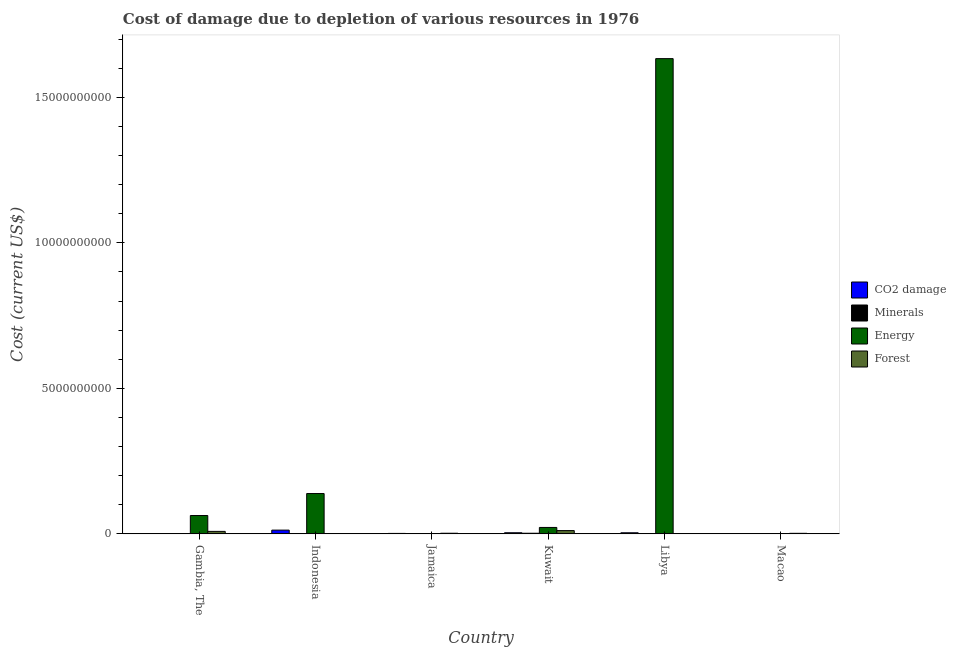Are the number of bars per tick equal to the number of legend labels?
Ensure brevity in your answer.  Yes. How many bars are there on the 1st tick from the right?
Offer a very short reply. 4. What is the label of the 4th group of bars from the left?
Keep it short and to the point. Kuwait. What is the cost of damage due to depletion of coal in Kuwait?
Make the answer very short. 3.84e+07. Across all countries, what is the maximum cost of damage due to depletion of energy?
Your answer should be compact. 1.63e+1. Across all countries, what is the minimum cost of damage due to depletion of minerals?
Your response must be concise. 8.73e+04. In which country was the cost of damage due to depletion of forests maximum?
Your answer should be compact. Kuwait. In which country was the cost of damage due to depletion of minerals minimum?
Offer a very short reply. Gambia, The. What is the total cost of damage due to depletion of minerals in the graph?
Ensure brevity in your answer.  4.59e+07. What is the difference between the cost of damage due to depletion of energy in Jamaica and that in Macao?
Offer a terse response. 2.94e+05. What is the difference between the cost of damage due to depletion of energy in Indonesia and the cost of damage due to depletion of minerals in Libya?
Offer a very short reply. 1.38e+09. What is the average cost of damage due to depletion of energy per country?
Your answer should be very brief. 3.09e+09. What is the difference between the cost of damage due to depletion of coal and cost of damage due to depletion of minerals in Gambia, The?
Your answer should be compact. 1.19e+05. In how many countries, is the cost of damage due to depletion of minerals greater than 9000000000 US$?
Your answer should be compact. 0. What is the ratio of the cost of damage due to depletion of forests in Gambia, The to that in Kuwait?
Make the answer very short. 0.76. Is the cost of damage due to depletion of minerals in Indonesia less than that in Macao?
Ensure brevity in your answer.  Yes. Is the difference between the cost of damage due to depletion of energy in Gambia, The and Indonesia greater than the difference between the cost of damage due to depletion of forests in Gambia, The and Indonesia?
Offer a terse response. No. What is the difference between the highest and the second highest cost of damage due to depletion of forests?
Your answer should be compact. 2.73e+07. What is the difference between the highest and the lowest cost of damage due to depletion of forests?
Provide a succinct answer. 1.12e+08. In how many countries, is the cost of damage due to depletion of minerals greater than the average cost of damage due to depletion of minerals taken over all countries?
Your answer should be compact. 2. Is it the case that in every country, the sum of the cost of damage due to depletion of energy and cost of damage due to depletion of coal is greater than the sum of cost of damage due to depletion of forests and cost of damage due to depletion of minerals?
Your response must be concise. No. What does the 4th bar from the left in Jamaica represents?
Your answer should be compact. Forest. What does the 4th bar from the right in Kuwait represents?
Make the answer very short. CO2 damage. Is it the case that in every country, the sum of the cost of damage due to depletion of coal and cost of damage due to depletion of minerals is greater than the cost of damage due to depletion of energy?
Keep it short and to the point. No. How many bars are there?
Your response must be concise. 24. What is the difference between two consecutive major ticks on the Y-axis?
Offer a very short reply. 5.00e+09. Are the values on the major ticks of Y-axis written in scientific E-notation?
Your answer should be very brief. No. Where does the legend appear in the graph?
Keep it short and to the point. Center right. How many legend labels are there?
Keep it short and to the point. 4. What is the title of the graph?
Give a very brief answer. Cost of damage due to depletion of various resources in 1976 . What is the label or title of the X-axis?
Your response must be concise. Country. What is the label or title of the Y-axis?
Your response must be concise. Cost (current US$). What is the Cost (current US$) of CO2 damage in Gambia, The?
Your answer should be compact. 2.06e+05. What is the Cost (current US$) of Minerals in Gambia, The?
Give a very brief answer. 8.73e+04. What is the Cost (current US$) in Energy in Gambia, The?
Keep it short and to the point. 6.30e+08. What is the Cost (current US$) in Forest in Gambia, The?
Make the answer very short. 8.54e+07. What is the Cost (current US$) in CO2 damage in Indonesia?
Provide a succinct answer. 1.28e+08. What is the Cost (current US$) in Minerals in Indonesia?
Keep it short and to the point. 6.60e+06. What is the Cost (current US$) of Energy in Indonesia?
Your response must be concise. 1.39e+09. What is the Cost (current US$) in Forest in Indonesia?
Make the answer very short. 1.20e+06. What is the Cost (current US$) in CO2 damage in Jamaica?
Your response must be concise. 1.51e+07. What is the Cost (current US$) in Minerals in Jamaica?
Offer a very short reply. 1.73e+06. What is the Cost (current US$) of Energy in Jamaica?
Offer a terse response. 4.30e+05. What is the Cost (current US$) in Forest in Jamaica?
Keep it short and to the point. 2.11e+07. What is the Cost (current US$) in CO2 damage in Kuwait?
Give a very brief answer. 3.84e+07. What is the Cost (current US$) in Minerals in Kuwait?
Your response must be concise. 2.10e+07. What is the Cost (current US$) in Energy in Kuwait?
Provide a succinct answer. 2.21e+08. What is the Cost (current US$) of Forest in Kuwait?
Offer a terse response. 1.13e+08. What is the Cost (current US$) in CO2 damage in Libya?
Your response must be concise. 3.72e+07. What is the Cost (current US$) in Minerals in Libya?
Offer a terse response. 9.51e+06. What is the Cost (current US$) in Energy in Libya?
Offer a terse response. 1.63e+1. What is the Cost (current US$) of Forest in Libya?
Provide a short and direct response. 6.67e+05. What is the Cost (current US$) in CO2 damage in Macao?
Your response must be concise. 5.26e+05. What is the Cost (current US$) in Minerals in Macao?
Give a very brief answer. 6.89e+06. What is the Cost (current US$) of Energy in Macao?
Your answer should be compact. 1.36e+05. What is the Cost (current US$) of Forest in Macao?
Your response must be concise. 1.89e+07. Across all countries, what is the maximum Cost (current US$) of CO2 damage?
Your response must be concise. 1.28e+08. Across all countries, what is the maximum Cost (current US$) in Minerals?
Offer a very short reply. 2.10e+07. Across all countries, what is the maximum Cost (current US$) in Energy?
Ensure brevity in your answer.  1.63e+1. Across all countries, what is the maximum Cost (current US$) of Forest?
Give a very brief answer. 1.13e+08. Across all countries, what is the minimum Cost (current US$) in CO2 damage?
Ensure brevity in your answer.  2.06e+05. Across all countries, what is the minimum Cost (current US$) in Minerals?
Make the answer very short. 8.73e+04. Across all countries, what is the minimum Cost (current US$) of Energy?
Provide a succinct answer. 1.36e+05. Across all countries, what is the minimum Cost (current US$) in Forest?
Provide a short and direct response. 6.67e+05. What is the total Cost (current US$) of CO2 damage in the graph?
Your answer should be very brief. 2.20e+08. What is the total Cost (current US$) of Minerals in the graph?
Make the answer very short. 4.59e+07. What is the total Cost (current US$) of Energy in the graph?
Keep it short and to the point. 1.86e+1. What is the total Cost (current US$) of Forest in the graph?
Your answer should be compact. 2.40e+08. What is the difference between the Cost (current US$) of CO2 damage in Gambia, The and that in Indonesia?
Ensure brevity in your answer.  -1.28e+08. What is the difference between the Cost (current US$) of Minerals in Gambia, The and that in Indonesia?
Offer a very short reply. -6.51e+06. What is the difference between the Cost (current US$) in Energy in Gambia, The and that in Indonesia?
Your answer should be very brief. -7.55e+08. What is the difference between the Cost (current US$) of Forest in Gambia, The and that in Indonesia?
Ensure brevity in your answer.  8.42e+07. What is the difference between the Cost (current US$) of CO2 damage in Gambia, The and that in Jamaica?
Provide a succinct answer. -1.49e+07. What is the difference between the Cost (current US$) in Minerals in Gambia, The and that in Jamaica?
Your answer should be compact. -1.64e+06. What is the difference between the Cost (current US$) in Energy in Gambia, The and that in Jamaica?
Provide a succinct answer. 6.30e+08. What is the difference between the Cost (current US$) of Forest in Gambia, The and that in Jamaica?
Make the answer very short. 6.44e+07. What is the difference between the Cost (current US$) in CO2 damage in Gambia, The and that in Kuwait?
Keep it short and to the point. -3.82e+07. What is the difference between the Cost (current US$) of Minerals in Gambia, The and that in Kuwait?
Provide a short and direct response. -2.10e+07. What is the difference between the Cost (current US$) of Energy in Gambia, The and that in Kuwait?
Offer a terse response. 4.10e+08. What is the difference between the Cost (current US$) of Forest in Gambia, The and that in Kuwait?
Your response must be concise. -2.73e+07. What is the difference between the Cost (current US$) in CO2 damage in Gambia, The and that in Libya?
Offer a very short reply. -3.70e+07. What is the difference between the Cost (current US$) in Minerals in Gambia, The and that in Libya?
Make the answer very short. -9.42e+06. What is the difference between the Cost (current US$) of Energy in Gambia, The and that in Libya?
Your response must be concise. -1.57e+1. What is the difference between the Cost (current US$) of Forest in Gambia, The and that in Libya?
Provide a succinct answer. 8.48e+07. What is the difference between the Cost (current US$) of CO2 damage in Gambia, The and that in Macao?
Offer a very short reply. -3.20e+05. What is the difference between the Cost (current US$) in Minerals in Gambia, The and that in Macao?
Your answer should be very brief. -6.80e+06. What is the difference between the Cost (current US$) in Energy in Gambia, The and that in Macao?
Your answer should be compact. 6.30e+08. What is the difference between the Cost (current US$) in Forest in Gambia, The and that in Macao?
Offer a terse response. 6.65e+07. What is the difference between the Cost (current US$) in CO2 damage in Indonesia and that in Jamaica?
Your answer should be very brief. 1.13e+08. What is the difference between the Cost (current US$) of Minerals in Indonesia and that in Jamaica?
Provide a short and direct response. 4.87e+06. What is the difference between the Cost (current US$) in Energy in Indonesia and that in Jamaica?
Keep it short and to the point. 1.38e+09. What is the difference between the Cost (current US$) of Forest in Indonesia and that in Jamaica?
Make the answer very short. -1.99e+07. What is the difference between the Cost (current US$) in CO2 damage in Indonesia and that in Kuwait?
Make the answer very short. 9.01e+07. What is the difference between the Cost (current US$) of Minerals in Indonesia and that in Kuwait?
Your response must be concise. -1.44e+07. What is the difference between the Cost (current US$) of Energy in Indonesia and that in Kuwait?
Your answer should be compact. 1.16e+09. What is the difference between the Cost (current US$) of Forest in Indonesia and that in Kuwait?
Keep it short and to the point. -1.12e+08. What is the difference between the Cost (current US$) of CO2 damage in Indonesia and that in Libya?
Your response must be concise. 9.12e+07. What is the difference between the Cost (current US$) of Minerals in Indonesia and that in Libya?
Offer a terse response. -2.91e+06. What is the difference between the Cost (current US$) of Energy in Indonesia and that in Libya?
Offer a very short reply. -1.49e+1. What is the difference between the Cost (current US$) in Forest in Indonesia and that in Libya?
Your response must be concise. 5.35e+05. What is the difference between the Cost (current US$) of CO2 damage in Indonesia and that in Macao?
Your answer should be compact. 1.28e+08. What is the difference between the Cost (current US$) of Minerals in Indonesia and that in Macao?
Offer a terse response. -2.88e+05. What is the difference between the Cost (current US$) in Energy in Indonesia and that in Macao?
Offer a terse response. 1.39e+09. What is the difference between the Cost (current US$) of Forest in Indonesia and that in Macao?
Give a very brief answer. -1.77e+07. What is the difference between the Cost (current US$) in CO2 damage in Jamaica and that in Kuwait?
Offer a very short reply. -2.33e+07. What is the difference between the Cost (current US$) of Minerals in Jamaica and that in Kuwait?
Offer a very short reply. -1.93e+07. What is the difference between the Cost (current US$) in Energy in Jamaica and that in Kuwait?
Provide a succinct answer. -2.20e+08. What is the difference between the Cost (current US$) in Forest in Jamaica and that in Kuwait?
Your answer should be very brief. -9.17e+07. What is the difference between the Cost (current US$) of CO2 damage in Jamaica and that in Libya?
Make the answer very short. -2.21e+07. What is the difference between the Cost (current US$) of Minerals in Jamaica and that in Libya?
Your response must be concise. -7.78e+06. What is the difference between the Cost (current US$) of Energy in Jamaica and that in Libya?
Offer a terse response. -1.63e+1. What is the difference between the Cost (current US$) in Forest in Jamaica and that in Libya?
Offer a very short reply. 2.04e+07. What is the difference between the Cost (current US$) in CO2 damage in Jamaica and that in Macao?
Your response must be concise. 1.46e+07. What is the difference between the Cost (current US$) of Minerals in Jamaica and that in Macao?
Offer a very short reply. -5.16e+06. What is the difference between the Cost (current US$) of Energy in Jamaica and that in Macao?
Your answer should be compact. 2.94e+05. What is the difference between the Cost (current US$) of Forest in Jamaica and that in Macao?
Make the answer very short. 2.19e+06. What is the difference between the Cost (current US$) in CO2 damage in Kuwait and that in Libya?
Provide a short and direct response. 1.16e+06. What is the difference between the Cost (current US$) in Minerals in Kuwait and that in Libya?
Offer a very short reply. 1.15e+07. What is the difference between the Cost (current US$) of Energy in Kuwait and that in Libya?
Offer a very short reply. -1.61e+1. What is the difference between the Cost (current US$) of Forest in Kuwait and that in Libya?
Provide a succinct answer. 1.12e+08. What is the difference between the Cost (current US$) in CO2 damage in Kuwait and that in Macao?
Your response must be concise. 3.79e+07. What is the difference between the Cost (current US$) in Minerals in Kuwait and that in Macao?
Provide a short and direct response. 1.42e+07. What is the difference between the Cost (current US$) in Energy in Kuwait and that in Macao?
Provide a succinct answer. 2.20e+08. What is the difference between the Cost (current US$) of Forest in Kuwait and that in Macao?
Keep it short and to the point. 9.39e+07. What is the difference between the Cost (current US$) of CO2 damage in Libya and that in Macao?
Give a very brief answer. 3.67e+07. What is the difference between the Cost (current US$) of Minerals in Libya and that in Macao?
Offer a terse response. 2.62e+06. What is the difference between the Cost (current US$) in Energy in Libya and that in Macao?
Your answer should be very brief. 1.63e+1. What is the difference between the Cost (current US$) of Forest in Libya and that in Macao?
Provide a succinct answer. -1.82e+07. What is the difference between the Cost (current US$) of CO2 damage in Gambia, The and the Cost (current US$) of Minerals in Indonesia?
Keep it short and to the point. -6.39e+06. What is the difference between the Cost (current US$) in CO2 damage in Gambia, The and the Cost (current US$) in Energy in Indonesia?
Your answer should be very brief. -1.39e+09. What is the difference between the Cost (current US$) in CO2 damage in Gambia, The and the Cost (current US$) in Forest in Indonesia?
Offer a terse response. -9.96e+05. What is the difference between the Cost (current US$) in Minerals in Gambia, The and the Cost (current US$) in Energy in Indonesia?
Your answer should be compact. -1.39e+09. What is the difference between the Cost (current US$) in Minerals in Gambia, The and the Cost (current US$) in Forest in Indonesia?
Keep it short and to the point. -1.11e+06. What is the difference between the Cost (current US$) in Energy in Gambia, The and the Cost (current US$) in Forest in Indonesia?
Your answer should be very brief. 6.29e+08. What is the difference between the Cost (current US$) in CO2 damage in Gambia, The and the Cost (current US$) in Minerals in Jamaica?
Keep it short and to the point. -1.52e+06. What is the difference between the Cost (current US$) of CO2 damage in Gambia, The and the Cost (current US$) of Energy in Jamaica?
Your response must be concise. -2.25e+05. What is the difference between the Cost (current US$) in CO2 damage in Gambia, The and the Cost (current US$) in Forest in Jamaica?
Offer a very short reply. -2.09e+07. What is the difference between the Cost (current US$) of Minerals in Gambia, The and the Cost (current US$) of Energy in Jamaica?
Provide a succinct answer. -3.43e+05. What is the difference between the Cost (current US$) in Minerals in Gambia, The and the Cost (current US$) in Forest in Jamaica?
Offer a terse response. -2.10e+07. What is the difference between the Cost (current US$) of Energy in Gambia, The and the Cost (current US$) of Forest in Jamaica?
Offer a very short reply. 6.09e+08. What is the difference between the Cost (current US$) of CO2 damage in Gambia, The and the Cost (current US$) of Minerals in Kuwait?
Your answer should be very brief. -2.08e+07. What is the difference between the Cost (current US$) of CO2 damage in Gambia, The and the Cost (current US$) of Energy in Kuwait?
Offer a terse response. -2.20e+08. What is the difference between the Cost (current US$) in CO2 damage in Gambia, The and the Cost (current US$) in Forest in Kuwait?
Your answer should be compact. -1.13e+08. What is the difference between the Cost (current US$) in Minerals in Gambia, The and the Cost (current US$) in Energy in Kuwait?
Keep it short and to the point. -2.20e+08. What is the difference between the Cost (current US$) in Minerals in Gambia, The and the Cost (current US$) in Forest in Kuwait?
Make the answer very short. -1.13e+08. What is the difference between the Cost (current US$) in Energy in Gambia, The and the Cost (current US$) in Forest in Kuwait?
Make the answer very short. 5.17e+08. What is the difference between the Cost (current US$) in CO2 damage in Gambia, The and the Cost (current US$) in Minerals in Libya?
Ensure brevity in your answer.  -9.30e+06. What is the difference between the Cost (current US$) in CO2 damage in Gambia, The and the Cost (current US$) in Energy in Libya?
Keep it short and to the point. -1.63e+1. What is the difference between the Cost (current US$) in CO2 damage in Gambia, The and the Cost (current US$) in Forest in Libya?
Your response must be concise. -4.61e+05. What is the difference between the Cost (current US$) of Minerals in Gambia, The and the Cost (current US$) of Energy in Libya?
Provide a succinct answer. -1.63e+1. What is the difference between the Cost (current US$) in Minerals in Gambia, The and the Cost (current US$) in Forest in Libya?
Your answer should be very brief. -5.79e+05. What is the difference between the Cost (current US$) in Energy in Gambia, The and the Cost (current US$) in Forest in Libya?
Make the answer very short. 6.29e+08. What is the difference between the Cost (current US$) in CO2 damage in Gambia, The and the Cost (current US$) in Minerals in Macao?
Make the answer very short. -6.68e+06. What is the difference between the Cost (current US$) in CO2 damage in Gambia, The and the Cost (current US$) in Energy in Macao?
Provide a short and direct response. 6.97e+04. What is the difference between the Cost (current US$) of CO2 damage in Gambia, The and the Cost (current US$) of Forest in Macao?
Offer a terse response. -1.87e+07. What is the difference between the Cost (current US$) in Minerals in Gambia, The and the Cost (current US$) in Energy in Macao?
Offer a very short reply. -4.88e+04. What is the difference between the Cost (current US$) in Minerals in Gambia, The and the Cost (current US$) in Forest in Macao?
Make the answer very short. -1.88e+07. What is the difference between the Cost (current US$) of Energy in Gambia, The and the Cost (current US$) of Forest in Macao?
Your answer should be compact. 6.11e+08. What is the difference between the Cost (current US$) of CO2 damage in Indonesia and the Cost (current US$) of Minerals in Jamaica?
Your answer should be compact. 1.27e+08. What is the difference between the Cost (current US$) of CO2 damage in Indonesia and the Cost (current US$) of Energy in Jamaica?
Offer a very short reply. 1.28e+08. What is the difference between the Cost (current US$) of CO2 damage in Indonesia and the Cost (current US$) of Forest in Jamaica?
Your response must be concise. 1.07e+08. What is the difference between the Cost (current US$) in Minerals in Indonesia and the Cost (current US$) in Energy in Jamaica?
Provide a short and direct response. 6.17e+06. What is the difference between the Cost (current US$) of Minerals in Indonesia and the Cost (current US$) of Forest in Jamaica?
Give a very brief answer. -1.45e+07. What is the difference between the Cost (current US$) of Energy in Indonesia and the Cost (current US$) of Forest in Jamaica?
Offer a very short reply. 1.36e+09. What is the difference between the Cost (current US$) in CO2 damage in Indonesia and the Cost (current US$) in Minerals in Kuwait?
Ensure brevity in your answer.  1.07e+08. What is the difference between the Cost (current US$) in CO2 damage in Indonesia and the Cost (current US$) in Energy in Kuwait?
Your answer should be compact. -9.20e+07. What is the difference between the Cost (current US$) in CO2 damage in Indonesia and the Cost (current US$) in Forest in Kuwait?
Ensure brevity in your answer.  1.58e+07. What is the difference between the Cost (current US$) of Minerals in Indonesia and the Cost (current US$) of Energy in Kuwait?
Offer a terse response. -2.14e+08. What is the difference between the Cost (current US$) in Minerals in Indonesia and the Cost (current US$) in Forest in Kuwait?
Your answer should be very brief. -1.06e+08. What is the difference between the Cost (current US$) in Energy in Indonesia and the Cost (current US$) in Forest in Kuwait?
Your answer should be compact. 1.27e+09. What is the difference between the Cost (current US$) of CO2 damage in Indonesia and the Cost (current US$) of Minerals in Libya?
Your answer should be very brief. 1.19e+08. What is the difference between the Cost (current US$) in CO2 damage in Indonesia and the Cost (current US$) in Energy in Libya?
Your response must be concise. -1.62e+1. What is the difference between the Cost (current US$) in CO2 damage in Indonesia and the Cost (current US$) in Forest in Libya?
Keep it short and to the point. 1.28e+08. What is the difference between the Cost (current US$) in Minerals in Indonesia and the Cost (current US$) in Energy in Libya?
Provide a succinct answer. -1.63e+1. What is the difference between the Cost (current US$) in Minerals in Indonesia and the Cost (current US$) in Forest in Libya?
Give a very brief answer. 5.93e+06. What is the difference between the Cost (current US$) in Energy in Indonesia and the Cost (current US$) in Forest in Libya?
Provide a succinct answer. 1.38e+09. What is the difference between the Cost (current US$) in CO2 damage in Indonesia and the Cost (current US$) in Minerals in Macao?
Ensure brevity in your answer.  1.22e+08. What is the difference between the Cost (current US$) in CO2 damage in Indonesia and the Cost (current US$) in Energy in Macao?
Ensure brevity in your answer.  1.28e+08. What is the difference between the Cost (current US$) of CO2 damage in Indonesia and the Cost (current US$) of Forest in Macao?
Give a very brief answer. 1.10e+08. What is the difference between the Cost (current US$) in Minerals in Indonesia and the Cost (current US$) in Energy in Macao?
Provide a succinct answer. 6.46e+06. What is the difference between the Cost (current US$) in Minerals in Indonesia and the Cost (current US$) in Forest in Macao?
Give a very brief answer. -1.23e+07. What is the difference between the Cost (current US$) of Energy in Indonesia and the Cost (current US$) of Forest in Macao?
Your answer should be very brief. 1.37e+09. What is the difference between the Cost (current US$) of CO2 damage in Jamaica and the Cost (current US$) of Minerals in Kuwait?
Ensure brevity in your answer.  -5.91e+06. What is the difference between the Cost (current US$) in CO2 damage in Jamaica and the Cost (current US$) in Energy in Kuwait?
Provide a succinct answer. -2.05e+08. What is the difference between the Cost (current US$) of CO2 damage in Jamaica and the Cost (current US$) of Forest in Kuwait?
Ensure brevity in your answer.  -9.76e+07. What is the difference between the Cost (current US$) in Minerals in Jamaica and the Cost (current US$) in Energy in Kuwait?
Offer a terse response. -2.19e+08. What is the difference between the Cost (current US$) of Minerals in Jamaica and the Cost (current US$) of Forest in Kuwait?
Give a very brief answer. -1.11e+08. What is the difference between the Cost (current US$) in Energy in Jamaica and the Cost (current US$) in Forest in Kuwait?
Give a very brief answer. -1.12e+08. What is the difference between the Cost (current US$) in CO2 damage in Jamaica and the Cost (current US$) in Minerals in Libya?
Ensure brevity in your answer.  5.63e+06. What is the difference between the Cost (current US$) of CO2 damage in Jamaica and the Cost (current US$) of Energy in Libya?
Make the answer very short. -1.63e+1. What is the difference between the Cost (current US$) in CO2 damage in Jamaica and the Cost (current US$) in Forest in Libya?
Your answer should be very brief. 1.45e+07. What is the difference between the Cost (current US$) of Minerals in Jamaica and the Cost (current US$) of Energy in Libya?
Offer a very short reply. -1.63e+1. What is the difference between the Cost (current US$) of Minerals in Jamaica and the Cost (current US$) of Forest in Libya?
Offer a terse response. 1.06e+06. What is the difference between the Cost (current US$) of Energy in Jamaica and the Cost (current US$) of Forest in Libya?
Offer a very short reply. -2.36e+05. What is the difference between the Cost (current US$) of CO2 damage in Jamaica and the Cost (current US$) of Minerals in Macao?
Your response must be concise. 8.25e+06. What is the difference between the Cost (current US$) of CO2 damage in Jamaica and the Cost (current US$) of Energy in Macao?
Your response must be concise. 1.50e+07. What is the difference between the Cost (current US$) of CO2 damage in Jamaica and the Cost (current US$) of Forest in Macao?
Your answer should be compact. -3.73e+06. What is the difference between the Cost (current US$) of Minerals in Jamaica and the Cost (current US$) of Energy in Macao?
Your answer should be compact. 1.59e+06. What is the difference between the Cost (current US$) in Minerals in Jamaica and the Cost (current US$) in Forest in Macao?
Provide a short and direct response. -1.71e+07. What is the difference between the Cost (current US$) of Energy in Jamaica and the Cost (current US$) of Forest in Macao?
Your response must be concise. -1.84e+07. What is the difference between the Cost (current US$) in CO2 damage in Kuwait and the Cost (current US$) in Minerals in Libya?
Make the answer very short. 2.89e+07. What is the difference between the Cost (current US$) of CO2 damage in Kuwait and the Cost (current US$) of Energy in Libya?
Your answer should be very brief. -1.63e+1. What is the difference between the Cost (current US$) of CO2 damage in Kuwait and the Cost (current US$) of Forest in Libya?
Ensure brevity in your answer.  3.77e+07. What is the difference between the Cost (current US$) of Minerals in Kuwait and the Cost (current US$) of Energy in Libya?
Keep it short and to the point. -1.63e+1. What is the difference between the Cost (current US$) of Minerals in Kuwait and the Cost (current US$) of Forest in Libya?
Provide a short and direct response. 2.04e+07. What is the difference between the Cost (current US$) of Energy in Kuwait and the Cost (current US$) of Forest in Libya?
Provide a short and direct response. 2.20e+08. What is the difference between the Cost (current US$) in CO2 damage in Kuwait and the Cost (current US$) in Minerals in Macao?
Make the answer very short. 3.15e+07. What is the difference between the Cost (current US$) in CO2 damage in Kuwait and the Cost (current US$) in Energy in Macao?
Provide a succinct answer. 3.83e+07. What is the difference between the Cost (current US$) in CO2 damage in Kuwait and the Cost (current US$) in Forest in Macao?
Keep it short and to the point. 1.95e+07. What is the difference between the Cost (current US$) of Minerals in Kuwait and the Cost (current US$) of Energy in Macao?
Provide a succinct answer. 2.09e+07. What is the difference between the Cost (current US$) of Minerals in Kuwait and the Cost (current US$) of Forest in Macao?
Your answer should be very brief. 2.18e+06. What is the difference between the Cost (current US$) in Energy in Kuwait and the Cost (current US$) in Forest in Macao?
Make the answer very short. 2.02e+08. What is the difference between the Cost (current US$) of CO2 damage in Libya and the Cost (current US$) of Minerals in Macao?
Ensure brevity in your answer.  3.04e+07. What is the difference between the Cost (current US$) in CO2 damage in Libya and the Cost (current US$) in Energy in Macao?
Ensure brevity in your answer.  3.71e+07. What is the difference between the Cost (current US$) of CO2 damage in Libya and the Cost (current US$) of Forest in Macao?
Your answer should be very brief. 1.84e+07. What is the difference between the Cost (current US$) of Minerals in Libya and the Cost (current US$) of Energy in Macao?
Your response must be concise. 9.37e+06. What is the difference between the Cost (current US$) in Minerals in Libya and the Cost (current US$) in Forest in Macao?
Keep it short and to the point. -9.37e+06. What is the difference between the Cost (current US$) in Energy in Libya and the Cost (current US$) in Forest in Macao?
Provide a succinct answer. 1.63e+1. What is the average Cost (current US$) of CO2 damage per country?
Give a very brief answer. 3.67e+07. What is the average Cost (current US$) in Minerals per country?
Offer a very short reply. 7.64e+06. What is the average Cost (current US$) in Energy per country?
Make the answer very short. 3.09e+09. What is the average Cost (current US$) in Forest per country?
Your answer should be very brief. 4.00e+07. What is the difference between the Cost (current US$) of CO2 damage and Cost (current US$) of Minerals in Gambia, The?
Give a very brief answer. 1.19e+05. What is the difference between the Cost (current US$) of CO2 damage and Cost (current US$) of Energy in Gambia, The?
Provide a short and direct response. -6.30e+08. What is the difference between the Cost (current US$) of CO2 damage and Cost (current US$) of Forest in Gambia, The?
Offer a very short reply. -8.52e+07. What is the difference between the Cost (current US$) of Minerals and Cost (current US$) of Energy in Gambia, The?
Keep it short and to the point. -6.30e+08. What is the difference between the Cost (current US$) in Minerals and Cost (current US$) in Forest in Gambia, The?
Make the answer very short. -8.53e+07. What is the difference between the Cost (current US$) of Energy and Cost (current US$) of Forest in Gambia, The?
Offer a very short reply. 5.45e+08. What is the difference between the Cost (current US$) of CO2 damage and Cost (current US$) of Minerals in Indonesia?
Your answer should be compact. 1.22e+08. What is the difference between the Cost (current US$) of CO2 damage and Cost (current US$) of Energy in Indonesia?
Your response must be concise. -1.26e+09. What is the difference between the Cost (current US$) in CO2 damage and Cost (current US$) in Forest in Indonesia?
Your answer should be compact. 1.27e+08. What is the difference between the Cost (current US$) of Minerals and Cost (current US$) of Energy in Indonesia?
Make the answer very short. -1.38e+09. What is the difference between the Cost (current US$) in Minerals and Cost (current US$) in Forest in Indonesia?
Make the answer very short. 5.40e+06. What is the difference between the Cost (current US$) of Energy and Cost (current US$) of Forest in Indonesia?
Make the answer very short. 1.38e+09. What is the difference between the Cost (current US$) in CO2 damage and Cost (current US$) in Minerals in Jamaica?
Provide a succinct answer. 1.34e+07. What is the difference between the Cost (current US$) of CO2 damage and Cost (current US$) of Energy in Jamaica?
Give a very brief answer. 1.47e+07. What is the difference between the Cost (current US$) of CO2 damage and Cost (current US$) of Forest in Jamaica?
Provide a short and direct response. -5.93e+06. What is the difference between the Cost (current US$) of Minerals and Cost (current US$) of Energy in Jamaica?
Your response must be concise. 1.30e+06. What is the difference between the Cost (current US$) of Minerals and Cost (current US$) of Forest in Jamaica?
Ensure brevity in your answer.  -1.93e+07. What is the difference between the Cost (current US$) of Energy and Cost (current US$) of Forest in Jamaica?
Your answer should be compact. -2.06e+07. What is the difference between the Cost (current US$) of CO2 damage and Cost (current US$) of Minerals in Kuwait?
Offer a terse response. 1.74e+07. What is the difference between the Cost (current US$) in CO2 damage and Cost (current US$) in Energy in Kuwait?
Your response must be concise. -1.82e+08. What is the difference between the Cost (current US$) of CO2 damage and Cost (current US$) of Forest in Kuwait?
Your answer should be very brief. -7.43e+07. What is the difference between the Cost (current US$) of Minerals and Cost (current US$) of Energy in Kuwait?
Keep it short and to the point. -1.99e+08. What is the difference between the Cost (current US$) of Minerals and Cost (current US$) of Forest in Kuwait?
Offer a terse response. -9.17e+07. What is the difference between the Cost (current US$) in Energy and Cost (current US$) in Forest in Kuwait?
Offer a terse response. 1.08e+08. What is the difference between the Cost (current US$) in CO2 damage and Cost (current US$) in Minerals in Libya?
Your answer should be very brief. 2.77e+07. What is the difference between the Cost (current US$) in CO2 damage and Cost (current US$) in Energy in Libya?
Your response must be concise. -1.63e+1. What is the difference between the Cost (current US$) in CO2 damage and Cost (current US$) in Forest in Libya?
Your answer should be very brief. 3.66e+07. What is the difference between the Cost (current US$) in Minerals and Cost (current US$) in Energy in Libya?
Make the answer very short. -1.63e+1. What is the difference between the Cost (current US$) of Minerals and Cost (current US$) of Forest in Libya?
Offer a very short reply. 8.84e+06. What is the difference between the Cost (current US$) of Energy and Cost (current US$) of Forest in Libya?
Your response must be concise. 1.63e+1. What is the difference between the Cost (current US$) in CO2 damage and Cost (current US$) in Minerals in Macao?
Your response must be concise. -6.36e+06. What is the difference between the Cost (current US$) in CO2 damage and Cost (current US$) in Energy in Macao?
Give a very brief answer. 3.90e+05. What is the difference between the Cost (current US$) of CO2 damage and Cost (current US$) of Forest in Macao?
Your answer should be compact. -1.83e+07. What is the difference between the Cost (current US$) in Minerals and Cost (current US$) in Energy in Macao?
Keep it short and to the point. 6.75e+06. What is the difference between the Cost (current US$) of Minerals and Cost (current US$) of Forest in Macao?
Give a very brief answer. -1.20e+07. What is the difference between the Cost (current US$) of Energy and Cost (current US$) of Forest in Macao?
Keep it short and to the point. -1.87e+07. What is the ratio of the Cost (current US$) of CO2 damage in Gambia, The to that in Indonesia?
Your answer should be compact. 0. What is the ratio of the Cost (current US$) of Minerals in Gambia, The to that in Indonesia?
Offer a very short reply. 0.01. What is the ratio of the Cost (current US$) of Energy in Gambia, The to that in Indonesia?
Give a very brief answer. 0.45. What is the ratio of the Cost (current US$) in Forest in Gambia, The to that in Indonesia?
Ensure brevity in your answer.  71.08. What is the ratio of the Cost (current US$) of CO2 damage in Gambia, The to that in Jamaica?
Your response must be concise. 0.01. What is the ratio of the Cost (current US$) in Minerals in Gambia, The to that in Jamaica?
Your answer should be very brief. 0.05. What is the ratio of the Cost (current US$) of Energy in Gambia, The to that in Jamaica?
Offer a terse response. 1463.56. What is the ratio of the Cost (current US$) of Forest in Gambia, The to that in Jamaica?
Your answer should be very brief. 4.05. What is the ratio of the Cost (current US$) of CO2 damage in Gambia, The to that in Kuwait?
Offer a terse response. 0.01. What is the ratio of the Cost (current US$) in Minerals in Gambia, The to that in Kuwait?
Make the answer very short. 0. What is the ratio of the Cost (current US$) of Energy in Gambia, The to that in Kuwait?
Offer a very short reply. 2.86. What is the ratio of the Cost (current US$) of Forest in Gambia, The to that in Kuwait?
Provide a succinct answer. 0.76. What is the ratio of the Cost (current US$) of CO2 damage in Gambia, The to that in Libya?
Offer a very short reply. 0.01. What is the ratio of the Cost (current US$) of Minerals in Gambia, The to that in Libya?
Your response must be concise. 0.01. What is the ratio of the Cost (current US$) of Energy in Gambia, The to that in Libya?
Ensure brevity in your answer.  0.04. What is the ratio of the Cost (current US$) of Forest in Gambia, The to that in Libya?
Give a very brief answer. 128.13. What is the ratio of the Cost (current US$) of CO2 damage in Gambia, The to that in Macao?
Your answer should be very brief. 0.39. What is the ratio of the Cost (current US$) of Minerals in Gambia, The to that in Macao?
Offer a terse response. 0.01. What is the ratio of the Cost (current US$) in Energy in Gambia, The to that in Macao?
Keep it short and to the point. 4629.03. What is the ratio of the Cost (current US$) of Forest in Gambia, The to that in Macao?
Your answer should be compact. 4.53. What is the ratio of the Cost (current US$) in CO2 damage in Indonesia to that in Jamaica?
Make the answer very short. 8.49. What is the ratio of the Cost (current US$) of Minerals in Indonesia to that in Jamaica?
Make the answer very short. 3.82. What is the ratio of the Cost (current US$) in Energy in Indonesia to that in Jamaica?
Provide a short and direct response. 3217.99. What is the ratio of the Cost (current US$) in Forest in Indonesia to that in Jamaica?
Your answer should be compact. 0.06. What is the ratio of the Cost (current US$) of CO2 damage in Indonesia to that in Kuwait?
Offer a terse response. 3.35. What is the ratio of the Cost (current US$) of Minerals in Indonesia to that in Kuwait?
Provide a succinct answer. 0.31. What is the ratio of the Cost (current US$) in Energy in Indonesia to that in Kuwait?
Your answer should be compact. 6.28. What is the ratio of the Cost (current US$) of Forest in Indonesia to that in Kuwait?
Offer a very short reply. 0.01. What is the ratio of the Cost (current US$) of CO2 damage in Indonesia to that in Libya?
Keep it short and to the point. 3.45. What is the ratio of the Cost (current US$) in Minerals in Indonesia to that in Libya?
Offer a terse response. 0.69. What is the ratio of the Cost (current US$) of Energy in Indonesia to that in Libya?
Ensure brevity in your answer.  0.08. What is the ratio of the Cost (current US$) in Forest in Indonesia to that in Libya?
Offer a very short reply. 1.8. What is the ratio of the Cost (current US$) in CO2 damage in Indonesia to that in Macao?
Ensure brevity in your answer.  244.29. What is the ratio of the Cost (current US$) in Minerals in Indonesia to that in Macao?
Give a very brief answer. 0.96. What is the ratio of the Cost (current US$) of Energy in Indonesia to that in Macao?
Ensure brevity in your answer.  1.02e+04. What is the ratio of the Cost (current US$) of Forest in Indonesia to that in Macao?
Your answer should be very brief. 0.06. What is the ratio of the Cost (current US$) in CO2 damage in Jamaica to that in Kuwait?
Give a very brief answer. 0.39. What is the ratio of the Cost (current US$) of Minerals in Jamaica to that in Kuwait?
Offer a terse response. 0.08. What is the ratio of the Cost (current US$) in Energy in Jamaica to that in Kuwait?
Make the answer very short. 0. What is the ratio of the Cost (current US$) of Forest in Jamaica to that in Kuwait?
Offer a terse response. 0.19. What is the ratio of the Cost (current US$) of CO2 damage in Jamaica to that in Libya?
Your answer should be compact. 0.41. What is the ratio of the Cost (current US$) in Minerals in Jamaica to that in Libya?
Your answer should be very brief. 0.18. What is the ratio of the Cost (current US$) of Energy in Jamaica to that in Libya?
Your answer should be compact. 0. What is the ratio of the Cost (current US$) in Forest in Jamaica to that in Libya?
Provide a succinct answer. 31.6. What is the ratio of the Cost (current US$) in CO2 damage in Jamaica to that in Macao?
Ensure brevity in your answer.  28.78. What is the ratio of the Cost (current US$) in Minerals in Jamaica to that in Macao?
Keep it short and to the point. 0.25. What is the ratio of the Cost (current US$) in Energy in Jamaica to that in Macao?
Offer a terse response. 3.16. What is the ratio of the Cost (current US$) of Forest in Jamaica to that in Macao?
Make the answer very short. 1.12. What is the ratio of the Cost (current US$) in CO2 damage in Kuwait to that in Libya?
Provide a succinct answer. 1.03. What is the ratio of the Cost (current US$) in Minerals in Kuwait to that in Libya?
Your response must be concise. 2.21. What is the ratio of the Cost (current US$) in Energy in Kuwait to that in Libya?
Offer a terse response. 0.01. What is the ratio of the Cost (current US$) in Forest in Kuwait to that in Libya?
Offer a very short reply. 169.1. What is the ratio of the Cost (current US$) in CO2 damage in Kuwait to that in Macao?
Offer a very short reply. 73.01. What is the ratio of the Cost (current US$) in Minerals in Kuwait to that in Macao?
Your answer should be compact. 3.06. What is the ratio of the Cost (current US$) in Energy in Kuwait to that in Macao?
Offer a very short reply. 1620.13. What is the ratio of the Cost (current US$) of Forest in Kuwait to that in Macao?
Your answer should be compact. 5.97. What is the ratio of the Cost (current US$) of CO2 damage in Libya to that in Macao?
Your answer should be very brief. 70.81. What is the ratio of the Cost (current US$) in Minerals in Libya to that in Macao?
Your answer should be compact. 1.38. What is the ratio of the Cost (current US$) in Energy in Libya to that in Macao?
Make the answer very short. 1.20e+05. What is the ratio of the Cost (current US$) in Forest in Libya to that in Macao?
Provide a short and direct response. 0.04. What is the difference between the highest and the second highest Cost (current US$) of CO2 damage?
Your answer should be compact. 9.01e+07. What is the difference between the highest and the second highest Cost (current US$) in Minerals?
Keep it short and to the point. 1.15e+07. What is the difference between the highest and the second highest Cost (current US$) in Energy?
Make the answer very short. 1.49e+1. What is the difference between the highest and the second highest Cost (current US$) in Forest?
Provide a succinct answer. 2.73e+07. What is the difference between the highest and the lowest Cost (current US$) in CO2 damage?
Make the answer very short. 1.28e+08. What is the difference between the highest and the lowest Cost (current US$) of Minerals?
Provide a short and direct response. 2.10e+07. What is the difference between the highest and the lowest Cost (current US$) of Energy?
Your answer should be compact. 1.63e+1. What is the difference between the highest and the lowest Cost (current US$) of Forest?
Provide a short and direct response. 1.12e+08. 